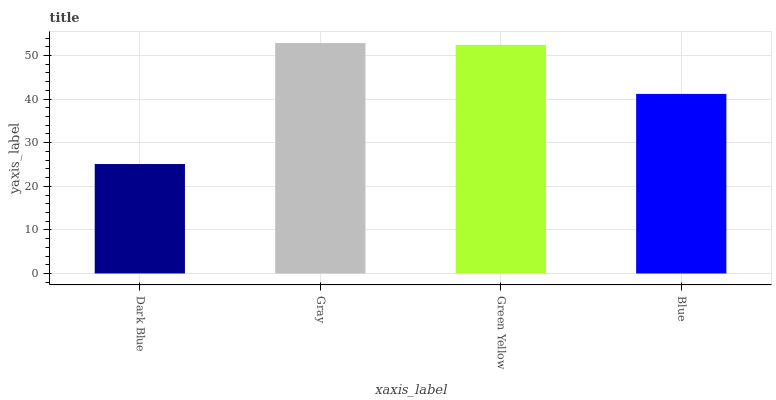Is Dark Blue the minimum?
Answer yes or no. Yes. Is Gray the maximum?
Answer yes or no. Yes. Is Green Yellow the minimum?
Answer yes or no. No. Is Green Yellow the maximum?
Answer yes or no. No. Is Gray greater than Green Yellow?
Answer yes or no. Yes. Is Green Yellow less than Gray?
Answer yes or no. Yes. Is Green Yellow greater than Gray?
Answer yes or no. No. Is Gray less than Green Yellow?
Answer yes or no. No. Is Green Yellow the high median?
Answer yes or no. Yes. Is Blue the low median?
Answer yes or no. Yes. Is Dark Blue the high median?
Answer yes or no. No. Is Dark Blue the low median?
Answer yes or no. No. 